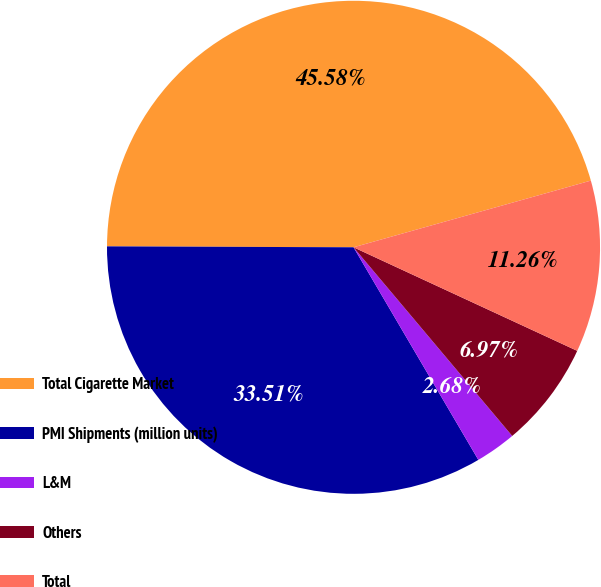Convert chart. <chart><loc_0><loc_0><loc_500><loc_500><pie_chart><fcel>Total Cigarette Market<fcel>PMI Shipments (million units)<fcel>L&M<fcel>Others<fcel>Total<nl><fcel>45.58%<fcel>33.51%<fcel>2.68%<fcel>6.97%<fcel>11.26%<nl></chart> 